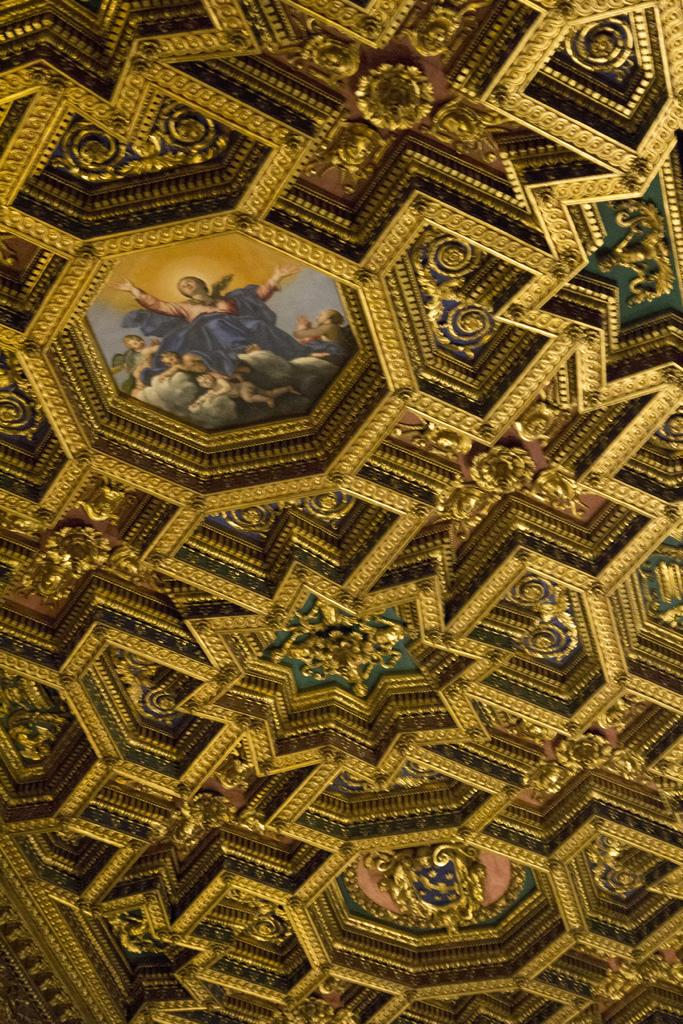What object can be seen in the image? There is a photo frame in the image. Where is the photo frame located? The photo frame is on a roof. What type of chin can be seen on the photo frame in the image? There is no chin present on the photo frame in the image, as it is an inanimate object. 